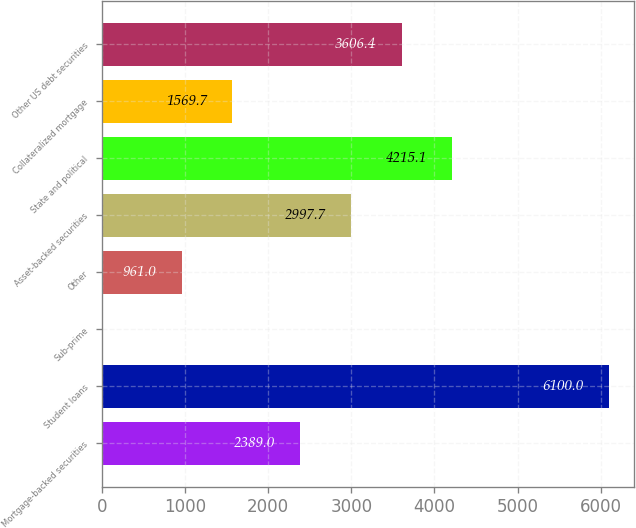Convert chart to OTSL. <chart><loc_0><loc_0><loc_500><loc_500><bar_chart><fcel>Mortgage-backed securities<fcel>Student loans<fcel>Sub-prime<fcel>Other<fcel>Asset-backed securities<fcel>State and political<fcel>Collateralized mortgage<fcel>Other US debt securities<nl><fcel>2389<fcel>6100<fcel>13<fcel>961<fcel>2997.7<fcel>4215.1<fcel>1569.7<fcel>3606.4<nl></chart> 